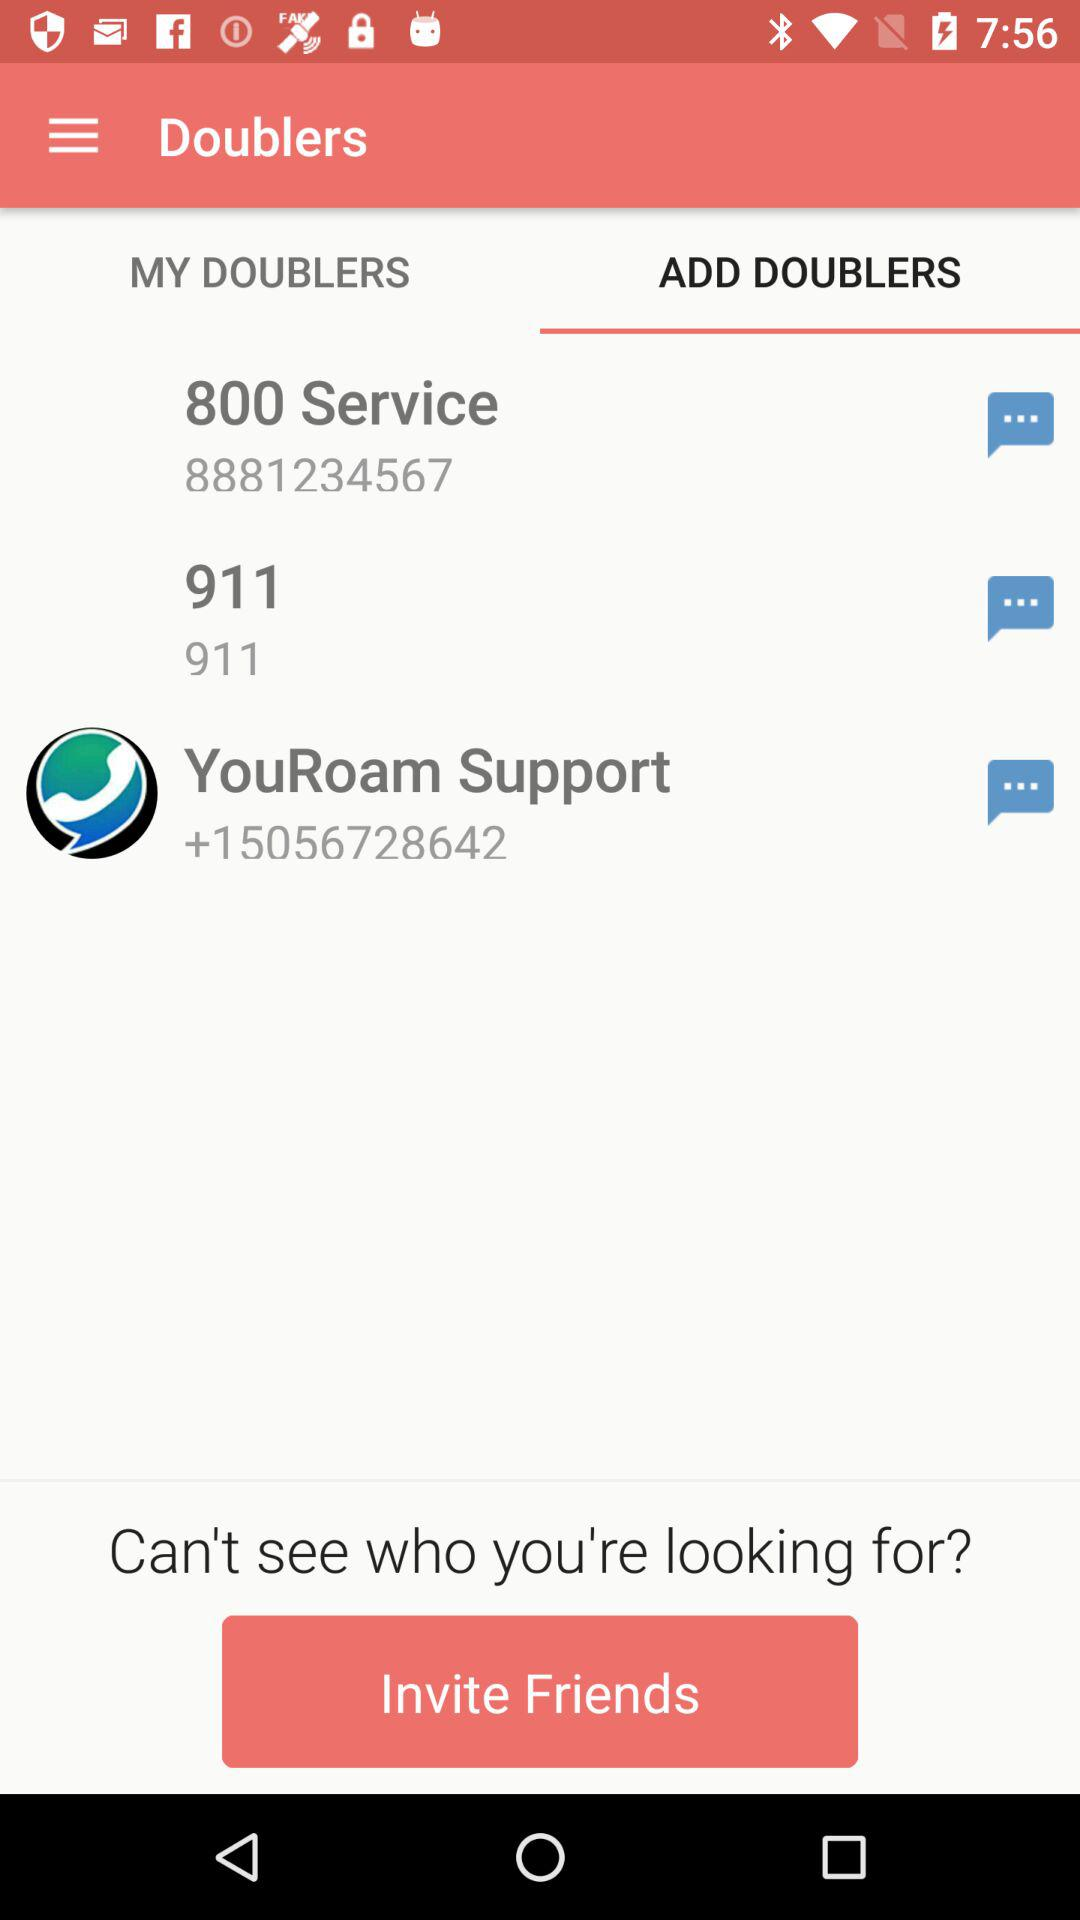What's the number for "YouRoam Support"? The number for "YouRoam Support" is +15056728642. 